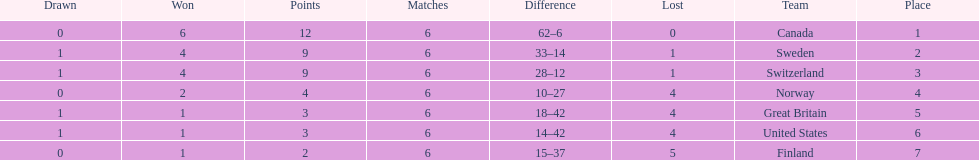Which country conceded the least goals? Finland. 